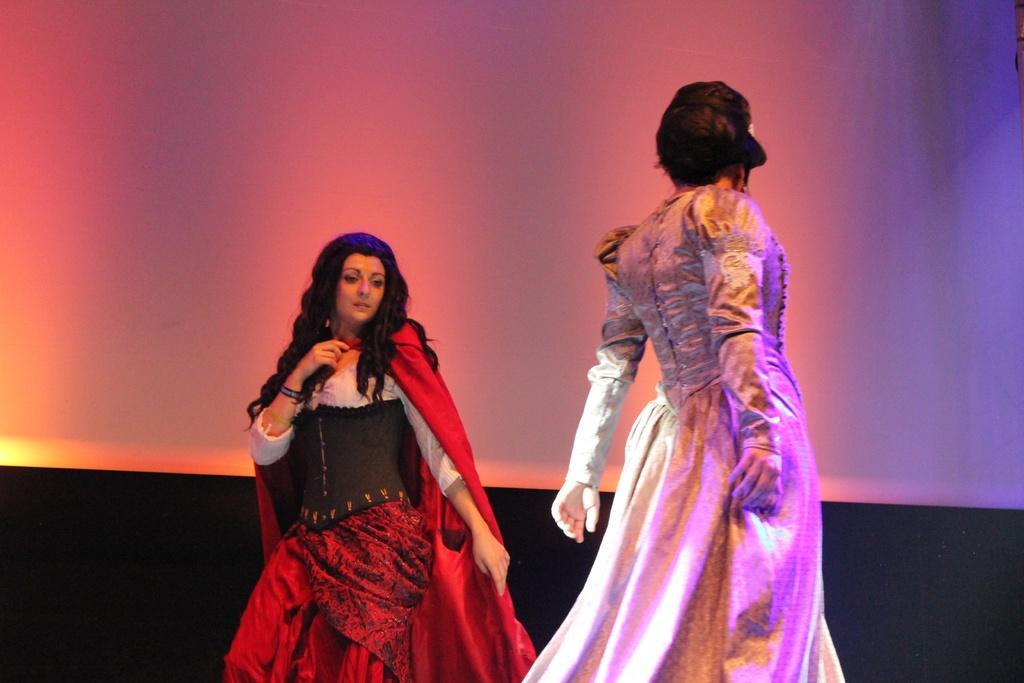How would you summarize this image in a sentence or two? In this image there are two women in the middle who are wearing the costumes. In the background there is a white color curtain. 